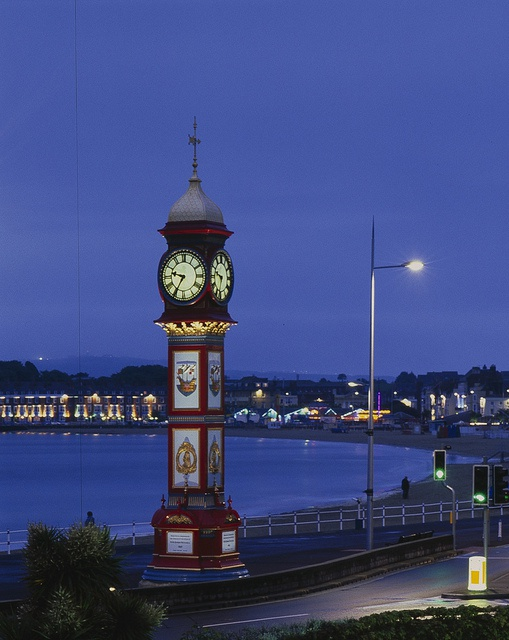Describe the objects in this image and their specific colors. I can see clock in blue, black, beige, and darkgray tones, clock in blue, black, darkgray, gray, and beige tones, traffic light in blue, black, gray, darkgreen, and lightgray tones, traffic light in blue, black, gray, and darkgreen tones, and traffic light in blue, black, darkgreen, darkgray, and lightgray tones in this image. 